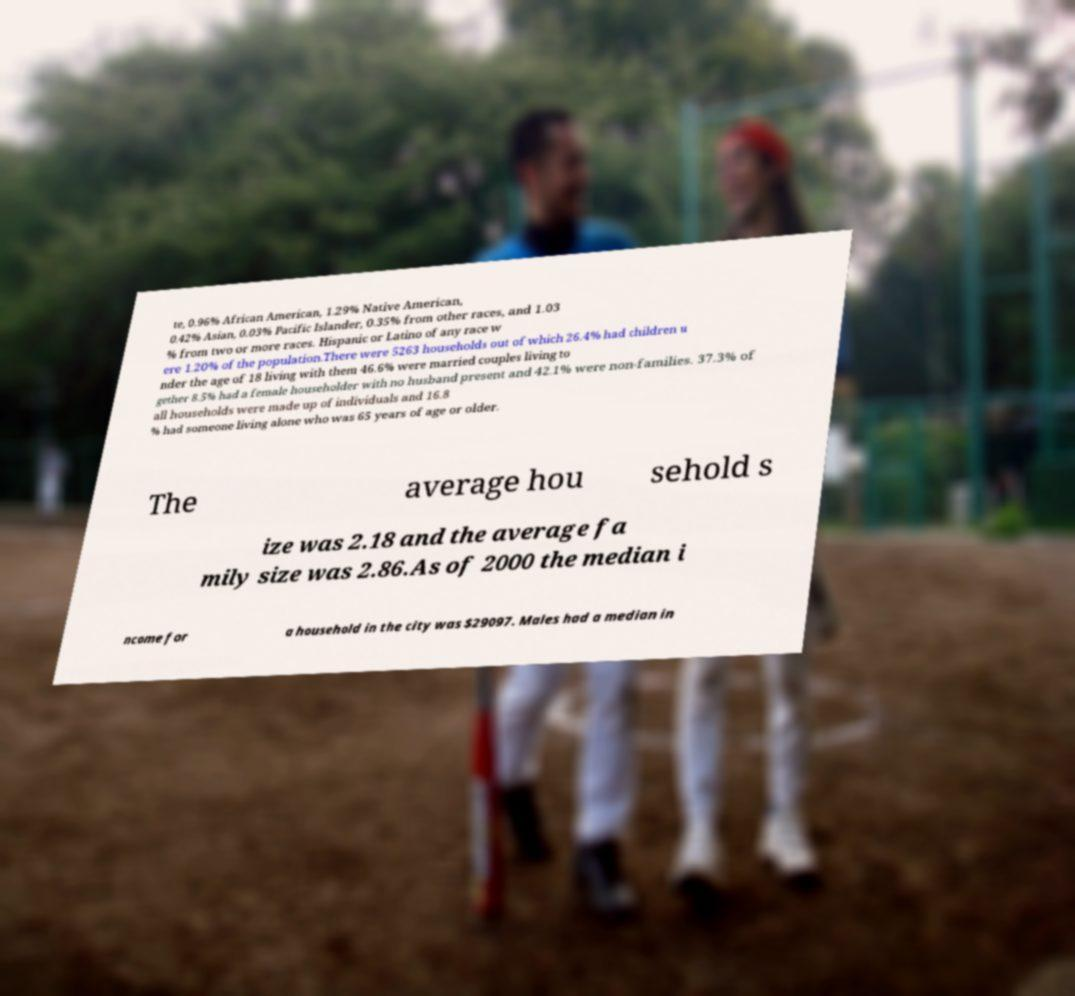Please read and relay the text visible in this image. What does it say? te, 0.96% African American, 1.29% Native American, 0.42% Asian, 0.03% Pacific Islander, 0.35% from other races, and 1.03 % from two or more races. Hispanic or Latino of any race w ere 1.20% of the population.There were 5263 households out of which 26.4% had children u nder the age of 18 living with them 46.6% were married couples living to gether 8.5% had a female householder with no husband present and 42.1% were non-families. 37.3% of all households were made up of individuals and 16.8 % had someone living alone who was 65 years of age or older. The average hou sehold s ize was 2.18 and the average fa mily size was 2.86.As of 2000 the median i ncome for a household in the city was $29097. Males had a median in 